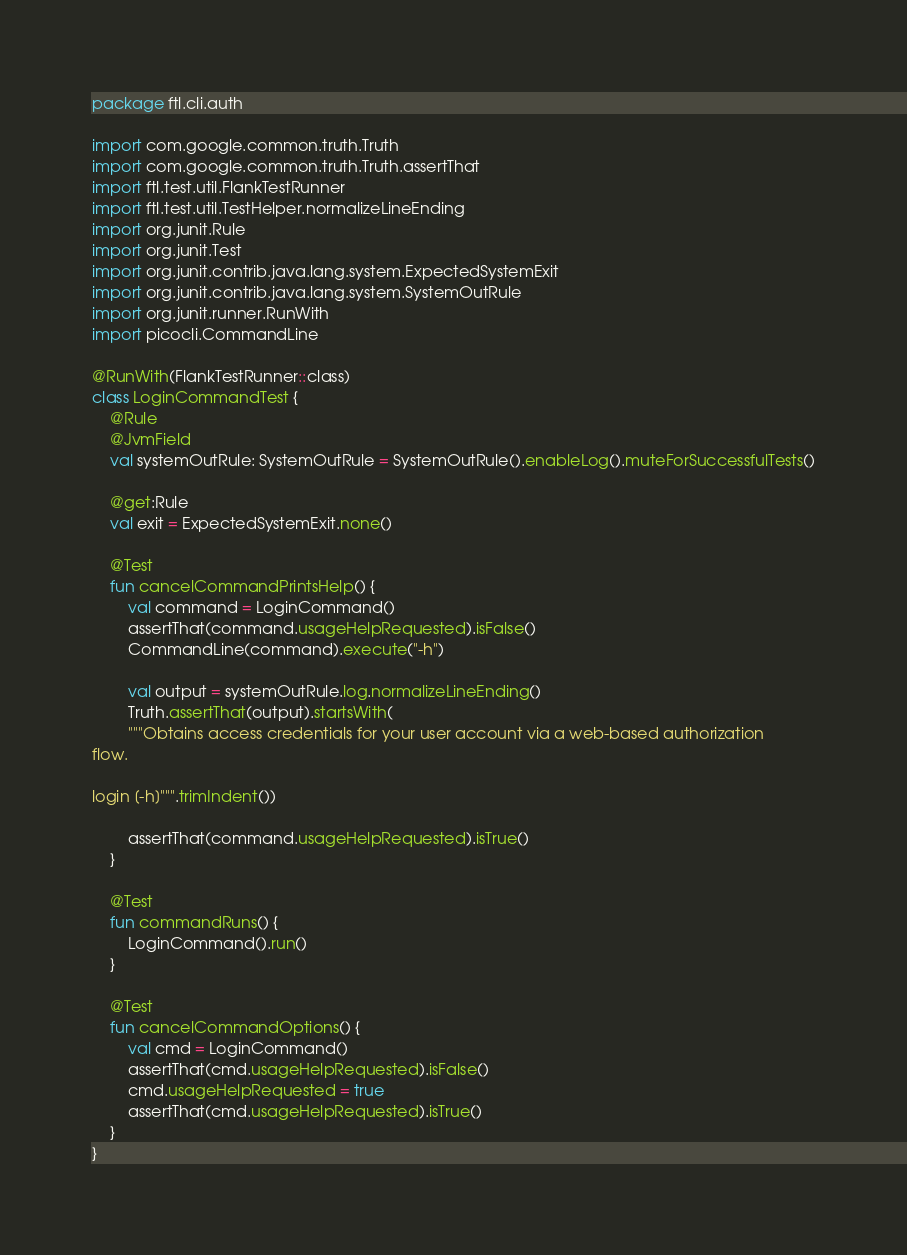Convert code to text. <code><loc_0><loc_0><loc_500><loc_500><_Kotlin_>package ftl.cli.auth

import com.google.common.truth.Truth
import com.google.common.truth.Truth.assertThat
import ftl.test.util.FlankTestRunner
import ftl.test.util.TestHelper.normalizeLineEnding
import org.junit.Rule
import org.junit.Test
import org.junit.contrib.java.lang.system.ExpectedSystemExit
import org.junit.contrib.java.lang.system.SystemOutRule
import org.junit.runner.RunWith
import picocli.CommandLine

@RunWith(FlankTestRunner::class)
class LoginCommandTest {
    @Rule
    @JvmField
    val systemOutRule: SystemOutRule = SystemOutRule().enableLog().muteForSuccessfulTests()

    @get:Rule
    val exit = ExpectedSystemExit.none()

    @Test
    fun cancelCommandPrintsHelp() {
        val command = LoginCommand()
        assertThat(command.usageHelpRequested).isFalse()
        CommandLine(command).execute("-h")

        val output = systemOutRule.log.normalizeLineEnding()
        Truth.assertThat(output).startsWith(
        """Obtains access credentials for your user account via a web-based authorization
flow.

login [-h]""".trimIndent())

        assertThat(command.usageHelpRequested).isTrue()
    }

    @Test
    fun commandRuns() {
        LoginCommand().run()
    }

    @Test
    fun cancelCommandOptions() {
        val cmd = LoginCommand()
        assertThat(cmd.usageHelpRequested).isFalse()
        cmd.usageHelpRequested = true
        assertThat(cmd.usageHelpRequested).isTrue()
    }
}
</code> 